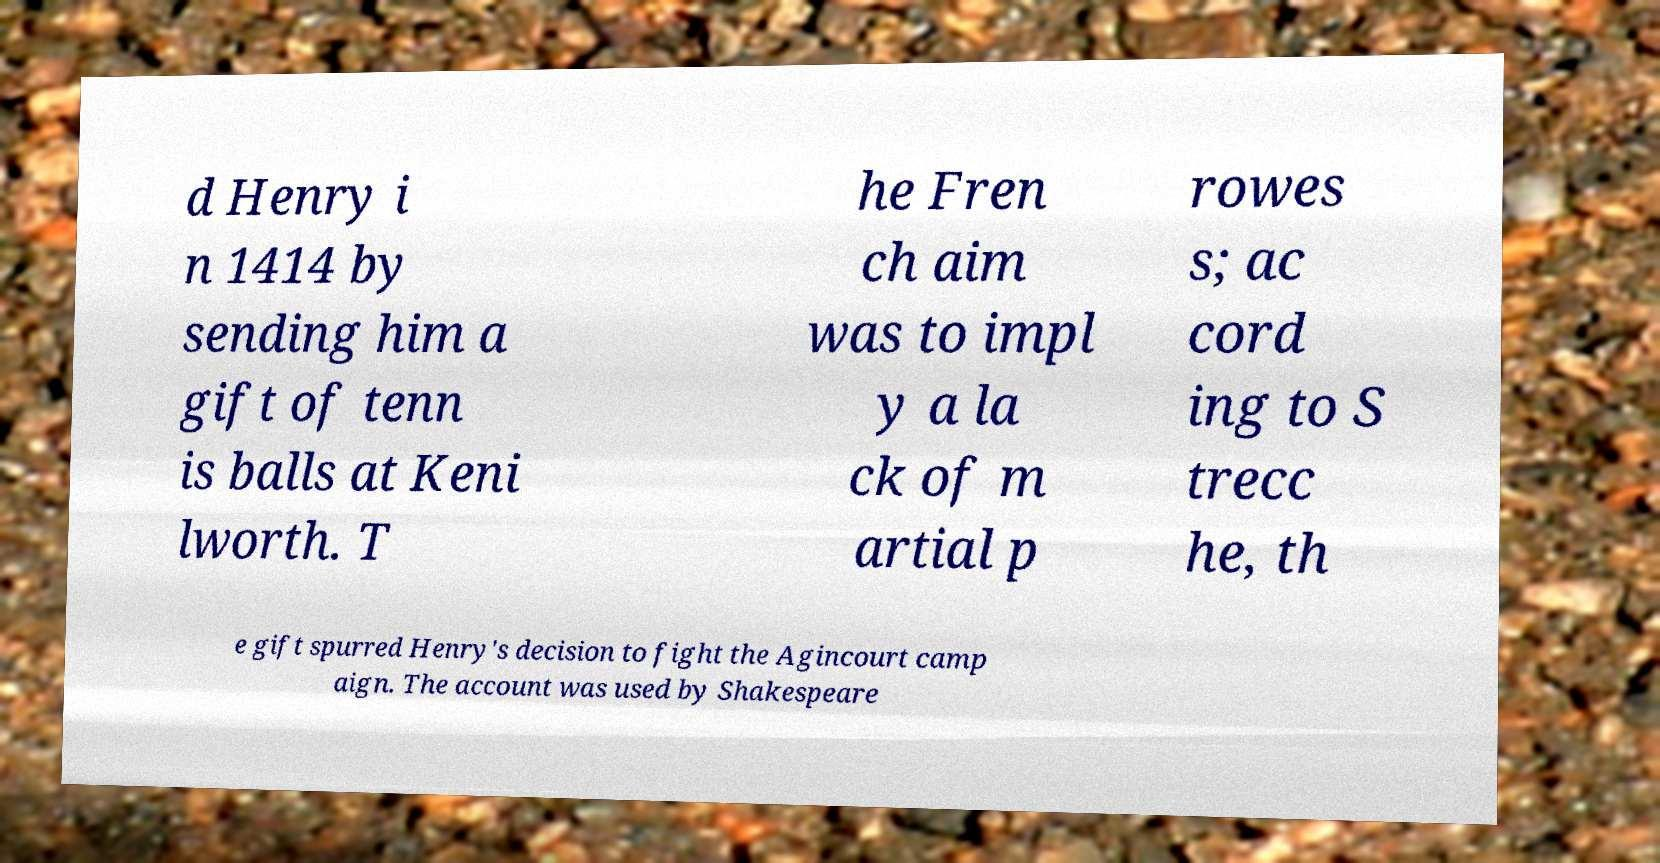What messages or text are displayed in this image? I need them in a readable, typed format. d Henry i n 1414 by sending him a gift of tenn is balls at Keni lworth. T he Fren ch aim was to impl y a la ck of m artial p rowes s; ac cord ing to S trecc he, th e gift spurred Henry's decision to fight the Agincourt camp aign. The account was used by Shakespeare 